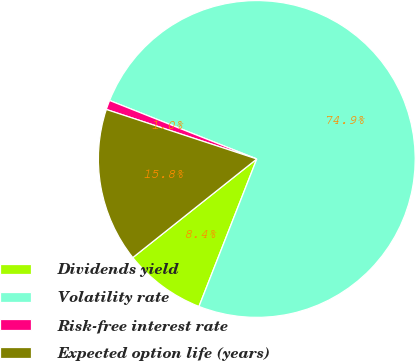<chart> <loc_0><loc_0><loc_500><loc_500><pie_chart><fcel>Dividends yield<fcel>Volatility rate<fcel>Risk-free interest rate<fcel>Expected option life (years)<nl><fcel>8.36%<fcel>74.92%<fcel>0.96%<fcel>15.75%<nl></chart> 